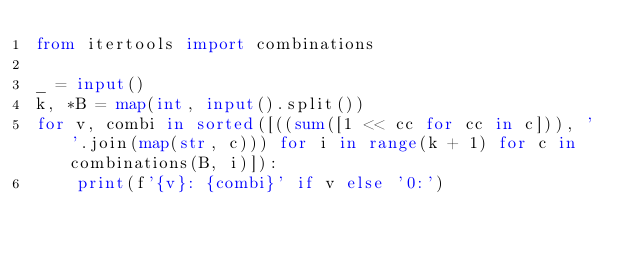<code> <loc_0><loc_0><loc_500><loc_500><_Python_>from itertools import combinations

_ = input()
k, *B = map(int, input().split())
for v, combi in sorted([((sum([1 << cc for cc in c])), ' '.join(map(str, c))) for i in range(k + 1) for c in combinations(B, i)]):
    print(f'{v}: {combi}' if v else '0:')


</code> 